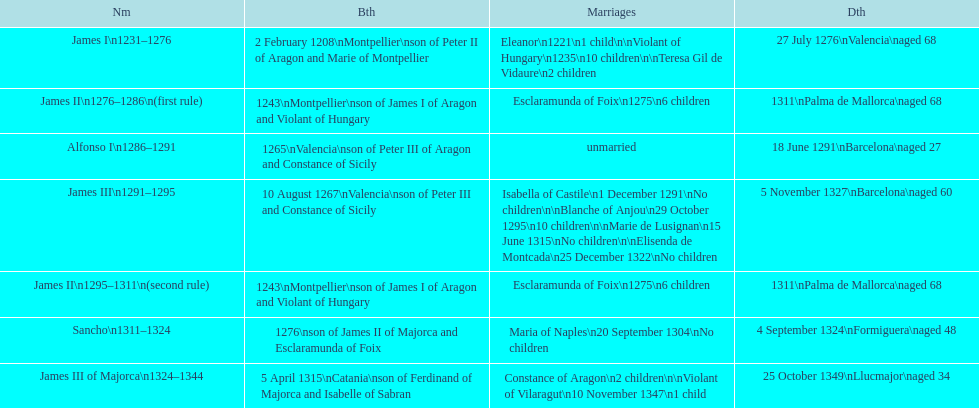Which pair of monarchs did not produce any children? Alfonso I, Sancho. 